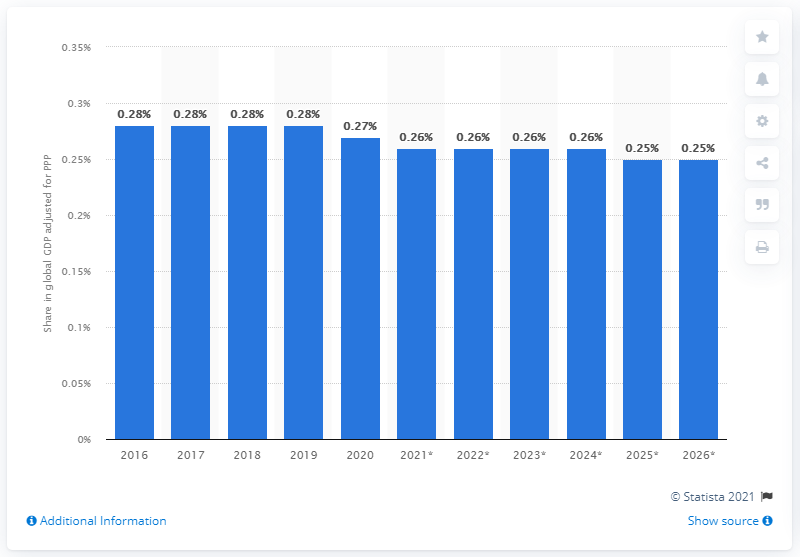Highlight a few significant elements in this photo. In 2020, Portugal's share in the global Gross Domestic Product (GDP) adjusted for Purchasing Power Parity (PPP) was 0.27%. 